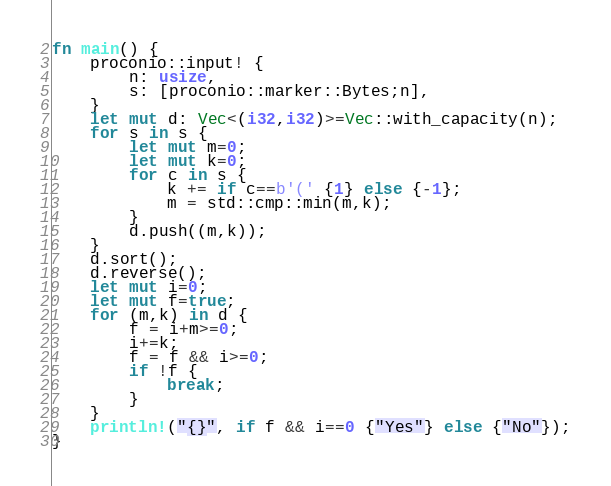<code> <loc_0><loc_0><loc_500><loc_500><_Rust_>fn main() {
    proconio::input! {
        n: usize,
        s: [proconio::marker::Bytes;n],
    }
    let mut d: Vec<(i32,i32)>=Vec::with_capacity(n);
    for s in s {
        let mut m=0;
        let mut k=0;
        for c in s {
            k += if c==b'(' {1} else {-1};
            m = std::cmp::min(m,k);
        }
        d.push((m,k));
    }
    d.sort();
    d.reverse();
    let mut i=0;
    let mut f=true;
    for (m,k) in d {
        f = i+m>=0;
        i+=k;
        f = f && i>=0;
        if !f {
            break;
        }
    }
    println!("{}", if f && i==0 {"Yes"} else {"No"});
}</code> 